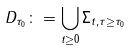<formula> <loc_0><loc_0><loc_500><loc_500>D _ { \tau _ { 0 } } \colon = \bigcup _ { t \geq 0 } \Sigma _ { t , \tau \geq \tau _ { 0 } }</formula> 